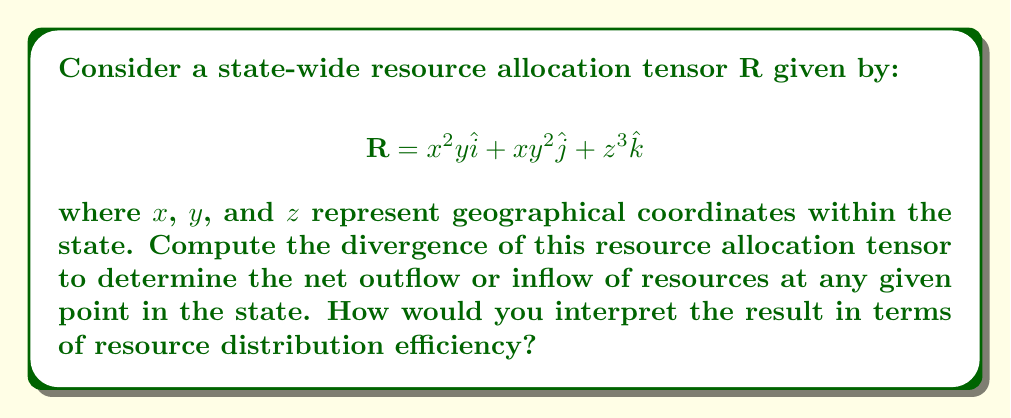Help me with this question. To solve this problem, we need to calculate the divergence of the resource allocation tensor $\mathbf{R}$. The divergence of a vector field in 3D Cartesian coordinates is given by:

$$\nabla \cdot \mathbf{R} = \frac{\partial R_x}{\partial x} + \frac{\partial R_y}{\partial y} + \frac{\partial R_z}{\partial z}$$

Where:
$R_x = x^2y$
$R_y = xy^2$
$R_z = z^3$

Step 1: Calculate $\frac{\partial R_x}{\partial x}$
$$\frac{\partial R_x}{\partial x} = \frac{\partial (x^2y)}{\partial x} = 2xy$$

Step 2: Calculate $\frac{\partial R_y}{\partial y}$
$$\frac{\partial R_y}{\partial y} = \frac{\partial (xy^2)}{\partial y} = 2xy$$

Step 3: Calculate $\frac{\partial R_z}{\partial z}$
$$\frac{\partial R_z}{\partial z} = \frac{\partial (z^3)}{\partial z} = 3z^2$$

Step 4: Sum the partial derivatives
$$\nabla \cdot \mathbf{R} = 2xy + 2xy + 3z^2 = 4xy + 3z^2$$

Interpretation: The divergence $4xy + 3z^2$ represents the net outflow of resources at any point $(x,y,z)$ in the state. Positive values indicate areas where resources are being distributed (sources), while negative values would indicate areas where resources are being collected (sinks). In this case, the divergence is always non-negative, suggesting that resources are being distributed throughout the state, with the distribution intensity varying based on location. The efficiency of resource distribution increases in areas with larger $x$, $y$, or $z$ coordinates.
Answer: $\nabla \cdot \mathbf{R} = 4xy + 3z^2$ 